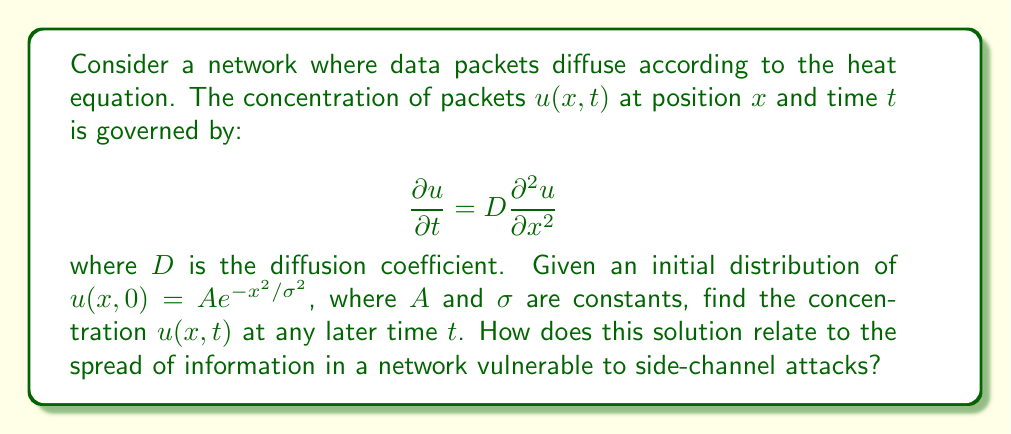Can you answer this question? To solve this problem, we'll follow these steps:

1) The general solution to the heat equation in one dimension is:

   $$u(x,t) = \frac{1}{\sqrt{4\pi Dt}} \int_{-\infty}^{\infty} u(\xi,0) e^{-\frac{(x-\xi)^2}{4Dt}} d\xi$$

2) Substituting our initial condition:

   $$u(x,t) = \frac{A}{\sqrt{4\pi Dt}} \int_{-\infty}^{\infty} e^{-\xi^2/\sigma^2} e^{-\frac{(x-\xi)^2}{4Dt}} d\xi$$

3) This integral can be evaluated using the convolution of two Gaussians. The result is:

   $$u(x,t) = \frac{A\sigma}{\sqrt{\sigma^2 + 4Dt}} e^{-\frac{x^2}{\sigma^2 + 4Dt}}$$

4) This solution shows that the initial Gaussian distribution spreads out over time, with its width increasing as $\sqrt{\sigma^2 + 4Dt}$.

5) In the context of network security and side-channel attacks:
   - The spreading of the distribution represents how information (or data packets) diffuses through the network over time.
   - The wider spread at later times indicates that information becomes more dispersed and potentially more vulnerable to interception.
   - The rate of spread, determined by $D$, could represent how quickly information propagates through the network, which is crucial for understanding potential vulnerabilities.
   - Side-channel attacks often rely on information leakage over time. This solution models how such leakage might occur in a network, helping identify vulnerable periods or network areas.
Answer: $u(x,t) = \frac{A\sigma}{\sqrt{\sigma^2 + 4Dt}} e^{-\frac{x^2}{\sigma^2 + 4Dt}}$ 